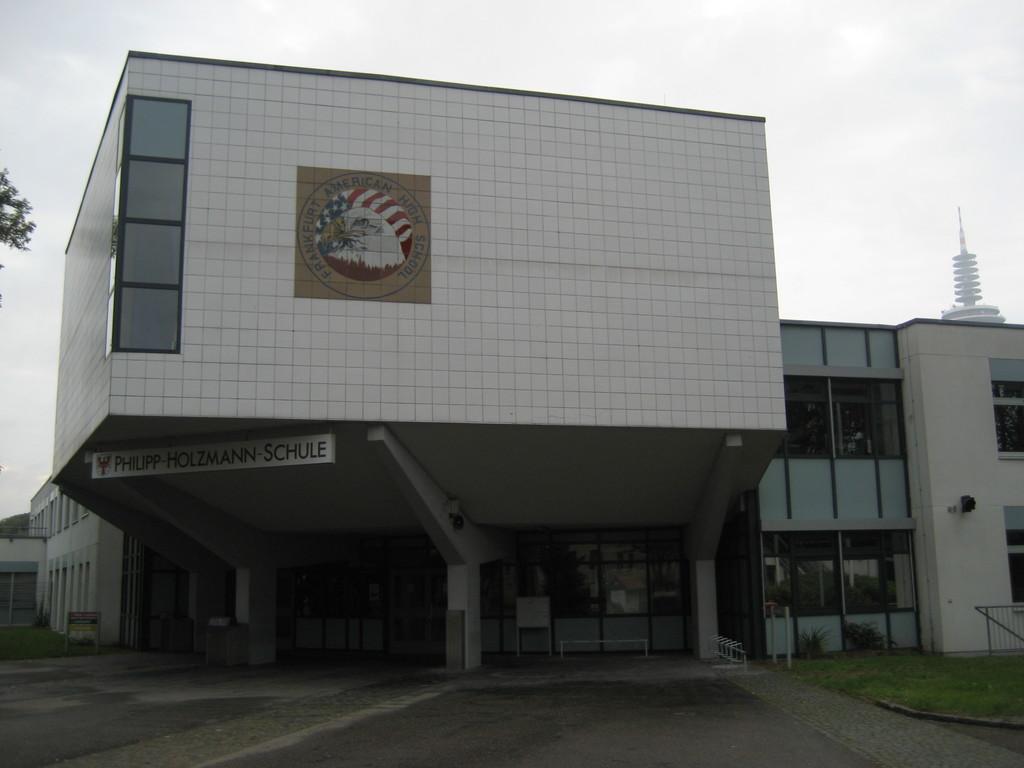Can you describe this image briefly? There is a building with pillars, glass walls. On the building there is a logo. Also there is a board with something written. In front of the building there is railing and grass. In the background there is sky. 